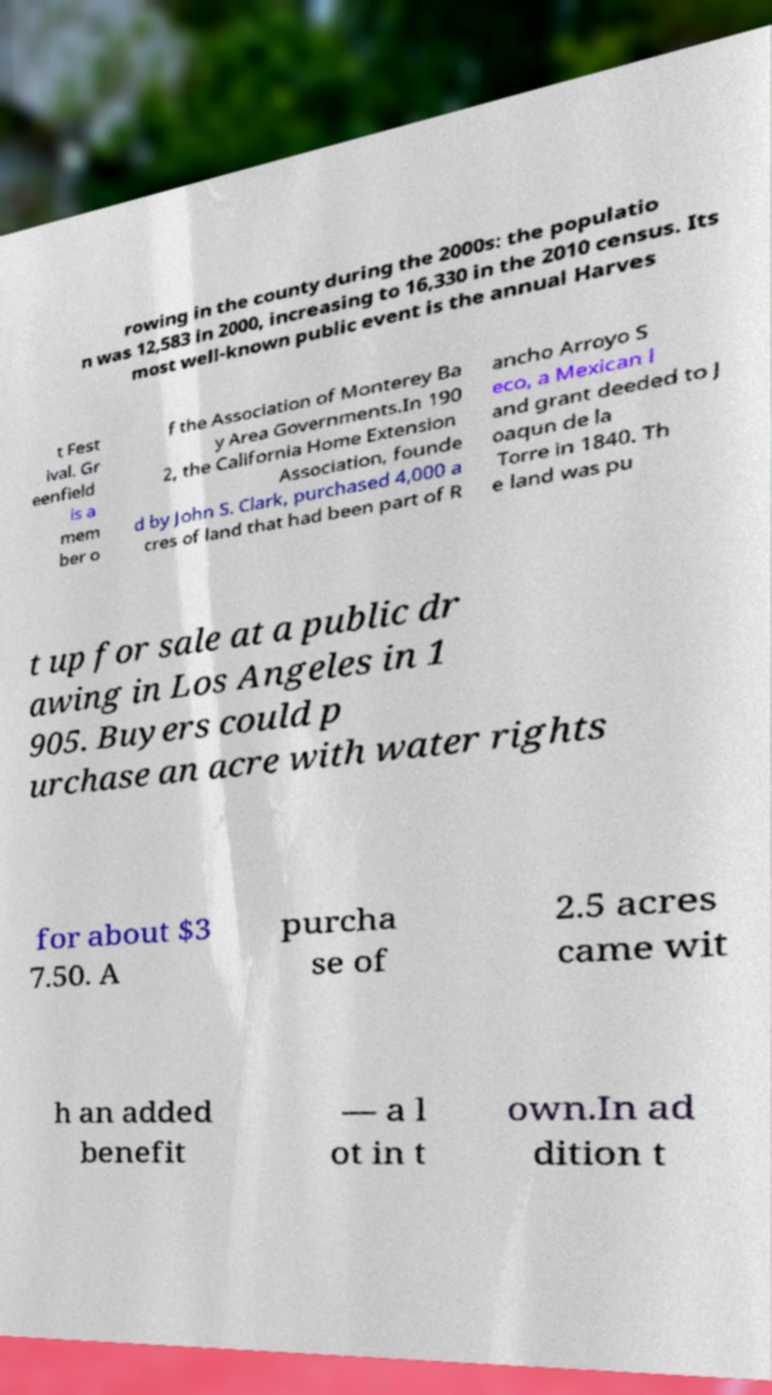Please identify and transcribe the text found in this image. rowing in the county during the 2000s: the populatio n was 12,583 in 2000, increasing to 16,330 in the 2010 census. Its most well-known public event is the annual Harves t Fest ival. Gr eenfield is a mem ber o f the Association of Monterey Ba y Area Governments.In 190 2, the California Home Extension Association, founde d by John S. Clark, purchased 4,000 a cres of land that had been part of R ancho Arroyo S eco, a Mexican l and grant deeded to J oaqun de la Torre in 1840. Th e land was pu t up for sale at a public dr awing in Los Angeles in 1 905. Buyers could p urchase an acre with water rights for about $3 7.50. A purcha se of 2.5 acres came wit h an added benefit — a l ot in t own.In ad dition t 